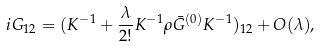<formula> <loc_0><loc_0><loc_500><loc_500>i G _ { 1 2 } = ( K ^ { - 1 } + \frac { \lambda } { 2 ! } K ^ { - 1 } \rho \bar { G } ^ { ( 0 ) } K ^ { - 1 } ) _ { 1 2 } + O ( \lambda ) ,</formula> 